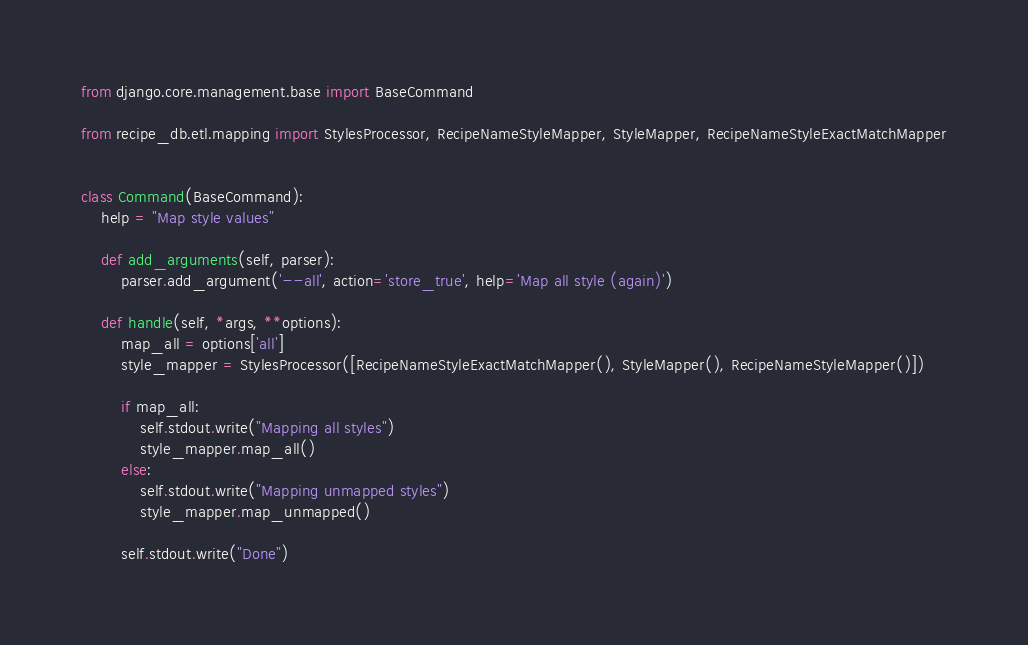Convert code to text. <code><loc_0><loc_0><loc_500><loc_500><_Python_>from django.core.management.base import BaseCommand

from recipe_db.etl.mapping import StylesProcessor, RecipeNameStyleMapper, StyleMapper, RecipeNameStyleExactMatchMapper


class Command(BaseCommand):
    help = "Map style values"

    def add_arguments(self, parser):
        parser.add_argument('--all', action='store_true', help='Map all style (again)')

    def handle(self, *args, **options):
        map_all = options['all']
        style_mapper = StylesProcessor([RecipeNameStyleExactMatchMapper(), StyleMapper(), RecipeNameStyleMapper()])

        if map_all:
            self.stdout.write("Mapping all styles")
            style_mapper.map_all()
        else:
            self.stdout.write("Mapping unmapped styles")
            style_mapper.map_unmapped()

        self.stdout.write("Done")
</code> 